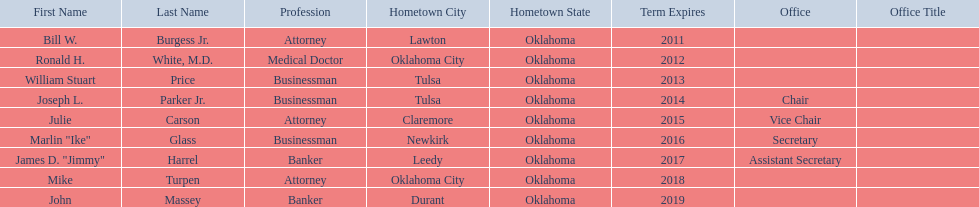What are the names of the oklahoma state regents for higher education? Bill W. Burgess Jr., Ronald H. White, M.D., William Stuart Price, Joseph L. Parker Jr., Julie Carson, Marlin "Ike" Glass, James D. "Jimmy" Harrel, Mike Turpen, John Massey. What is ronald h. white's hometown? Oklahoma City. Which other regent has the same hometown as above? Mike Turpen. 